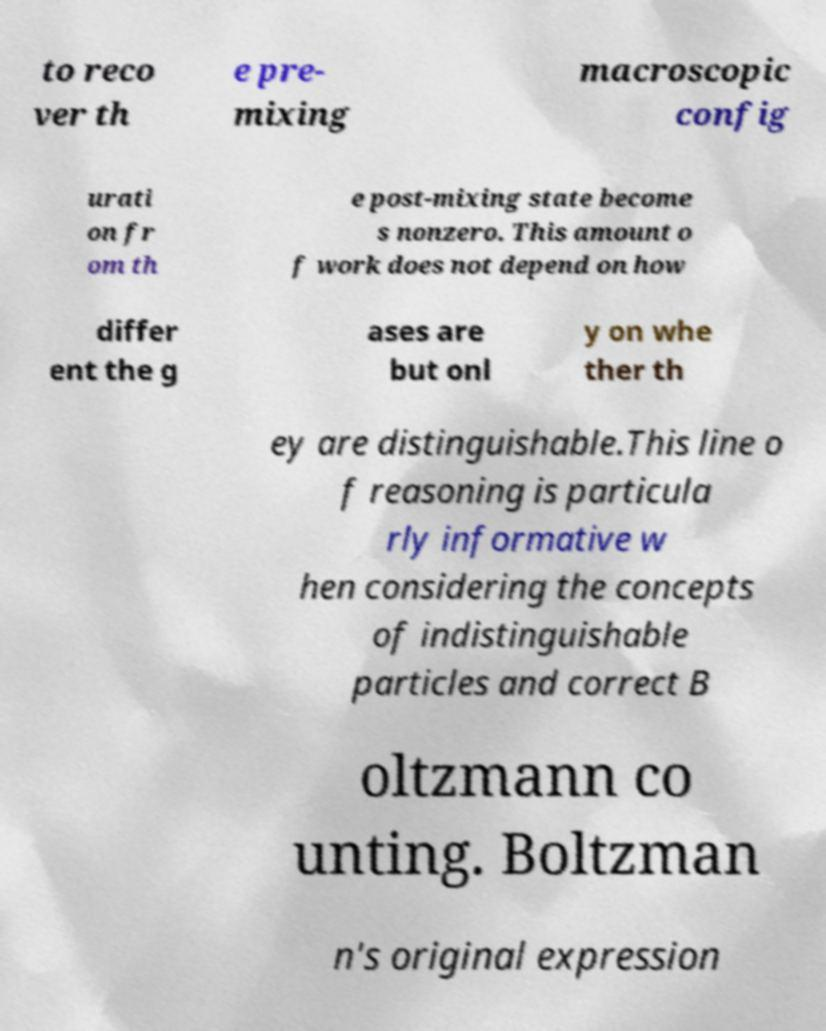I need the written content from this picture converted into text. Can you do that? to reco ver th e pre- mixing macroscopic config urati on fr om th e post-mixing state become s nonzero. This amount o f work does not depend on how differ ent the g ases are but onl y on whe ther th ey are distinguishable.This line o f reasoning is particula rly informative w hen considering the concepts of indistinguishable particles and correct B oltzmann co unting. Boltzman n's original expression 